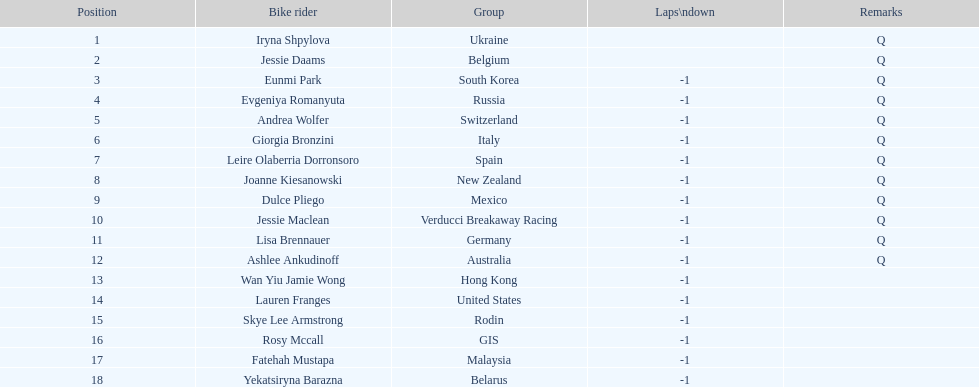How many cyclist do not have -1 laps down? 2. 